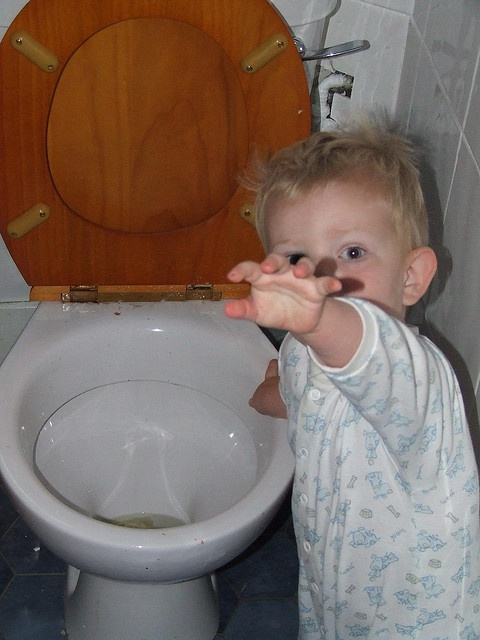Describe the objects in this image and their specific colors. I can see toilet in gray, maroon, and darkgray tones and people in gray and darkgray tones in this image. 